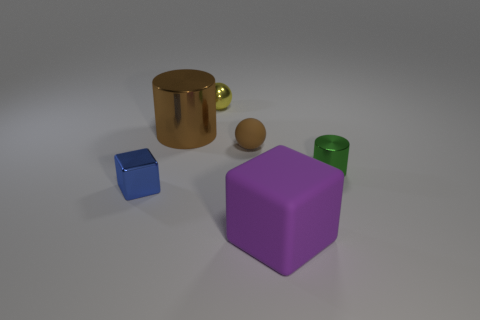What is the shape of the tiny matte object? sphere 